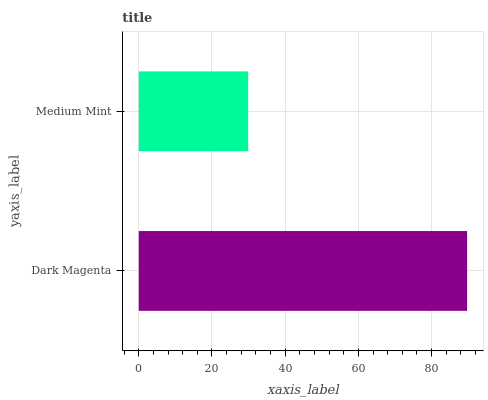Is Medium Mint the minimum?
Answer yes or no. Yes. Is Dark Magenta the maximum?
Answer yes or no. Yes. Is Medium Mint the maximum?
Answer yes or no. No. Is Dark Magenta greater than Medium Mint?
Answer yes or no. Yes. Is Medium Mint less than Dark Magenta?
Answer yes or no. Yes. Is Medium Mint greater than Dark Magenta?
Answer yes or no. No. Is Dark Magenta less than Medium Mint?
Answer yes or no. No. Is Dark Magenta the high median?
Answer yes or no. Yes. Is Medium Mint the low median?
Answer yes or no. Yes. Is Medium Mint the high median?
Answer yes or no. No. Is Dark Magenta the low median?
Answer yes or no. No. 